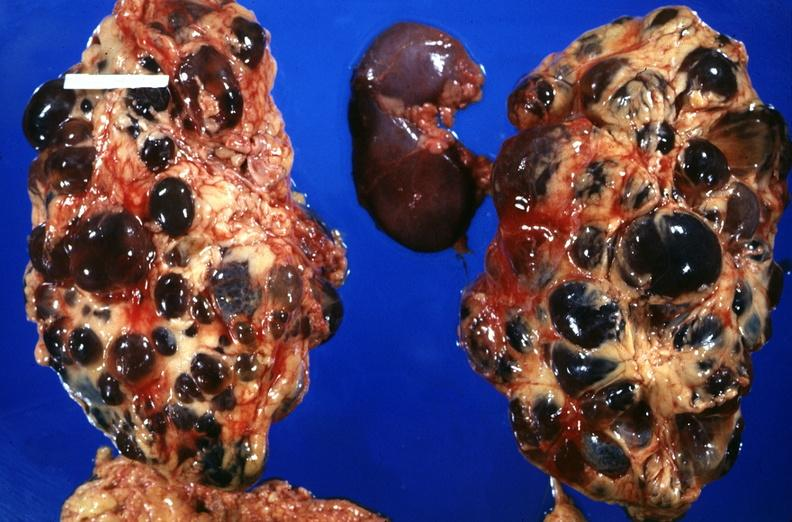does this image show kidney, adult polycystic kidney?
Answer the question using a single word or phrase. Yes 